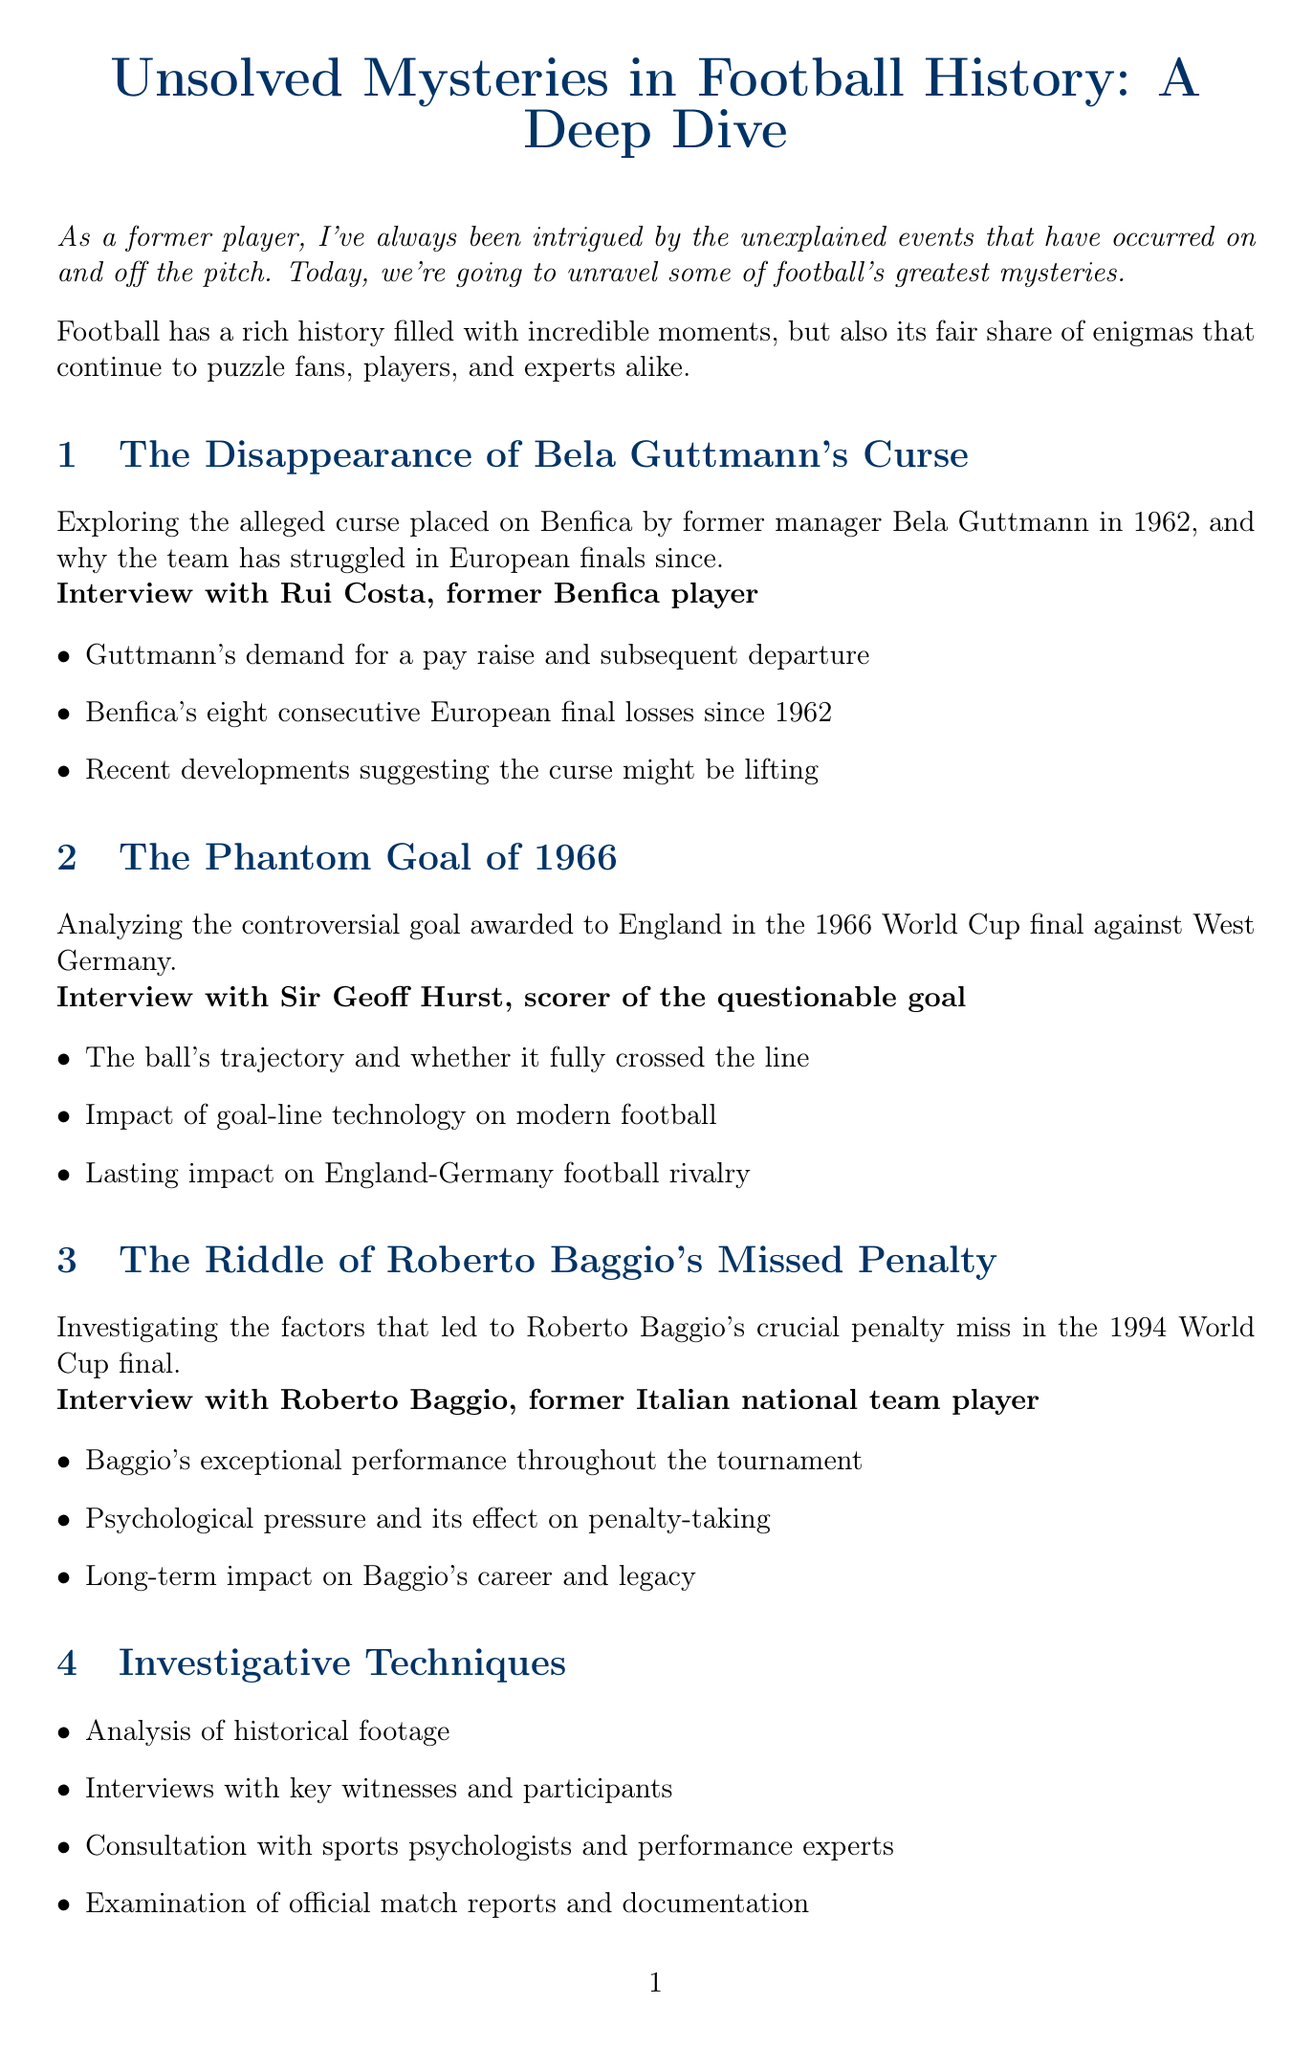What is the title of the report? The title of the report is stated at the beginning, which summarizes the topic discussed.
Answer: Unsolved Mysteries in Football History: A Deep Dive Who was interviewed about Bela Guttmann's Curse? The document specifies who was interviewed for this particular mystery, representing the perspective of a former player.
Answer: Rui Costa What year did Bela Guttmann allegedly place the curse? The report mentions the year associated with the curse placed on Benfica for context.
Answer: 1962 How many European finals has Benfica lost since 1962? The document provides a specific number related to Benfica's performance in European finals after the curse was placed.
Answer: Eight Which World Cup final features the Phantom Goal? The document references a specific World Cup final in relation to the controversial goal analyzed.
Answer: 1966 What psychological factors are explored in the report? The document discusses the impact of psychological factors on players, particularly in high-pressure situations.
Answer: Psychological pressure Who is a member of the expert panel focusing on officiating challenges? The report lists individuals on the expert panel and their areas of expertise, helping to identify them.
Answer: Howard Webb What investigative technique involves analyzing historical footage? The report outlines various techniques utilized in the investigation to uncover the mysteries discussed.
Answer: Analysis of historical footage What was the impact of the Phantom Goal on football rivalry? The document indicates enduring consequences of the goal on specific rivalries, emphasizing its significance.
Answer: Lasting impact on England-Germany football rivalry 